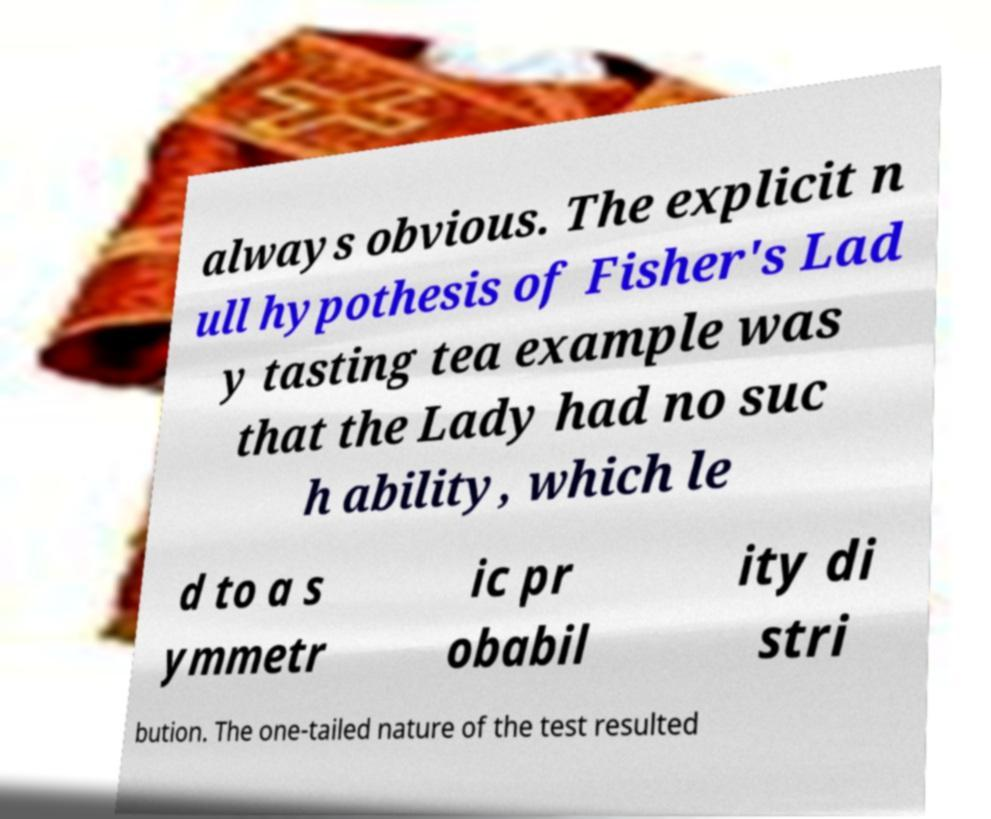I need the written content from this picture converted into text. Can you do that? always obvious. The explicit n ull hypothesis of Fisher's Lad y tasting tea example was that the Lady had no suc h ability, which le d to a s ymmetr ic pr obabil ity di stri bution. The one-tailed nature of the test resulted 